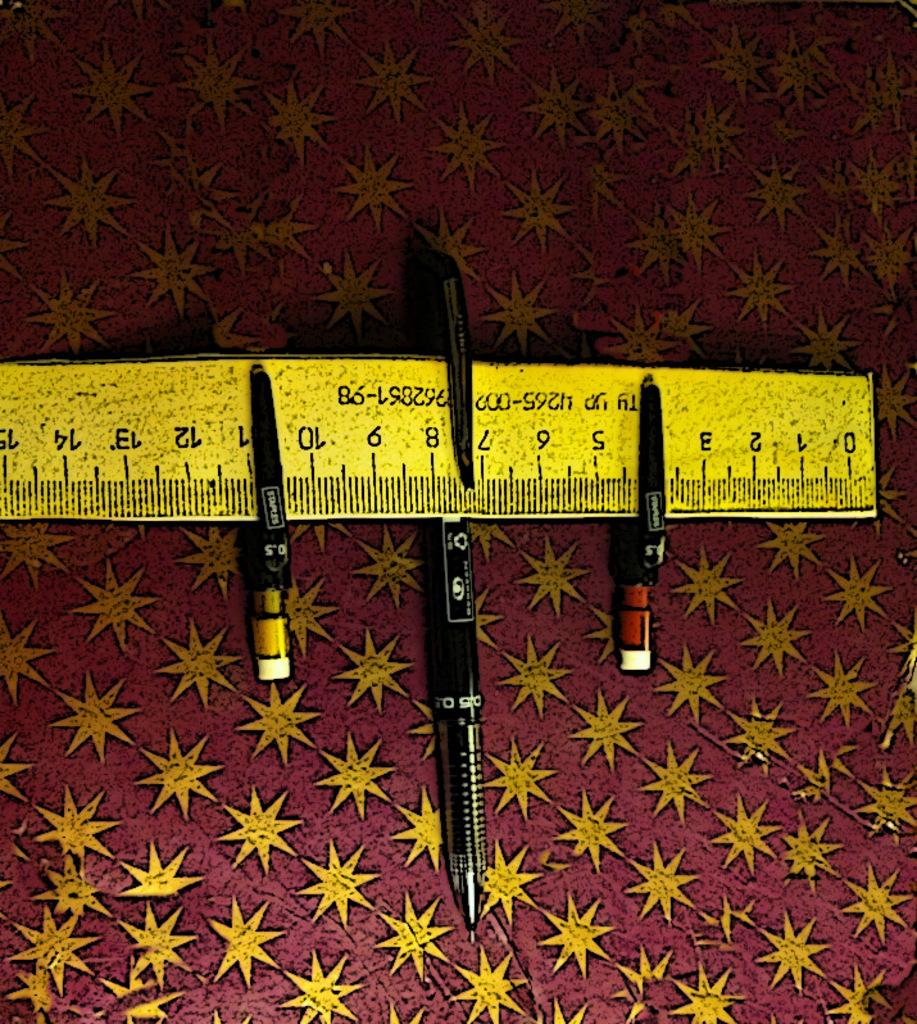<image>
Summarize the visual content of the image. a ruler that has the number 0 on it 